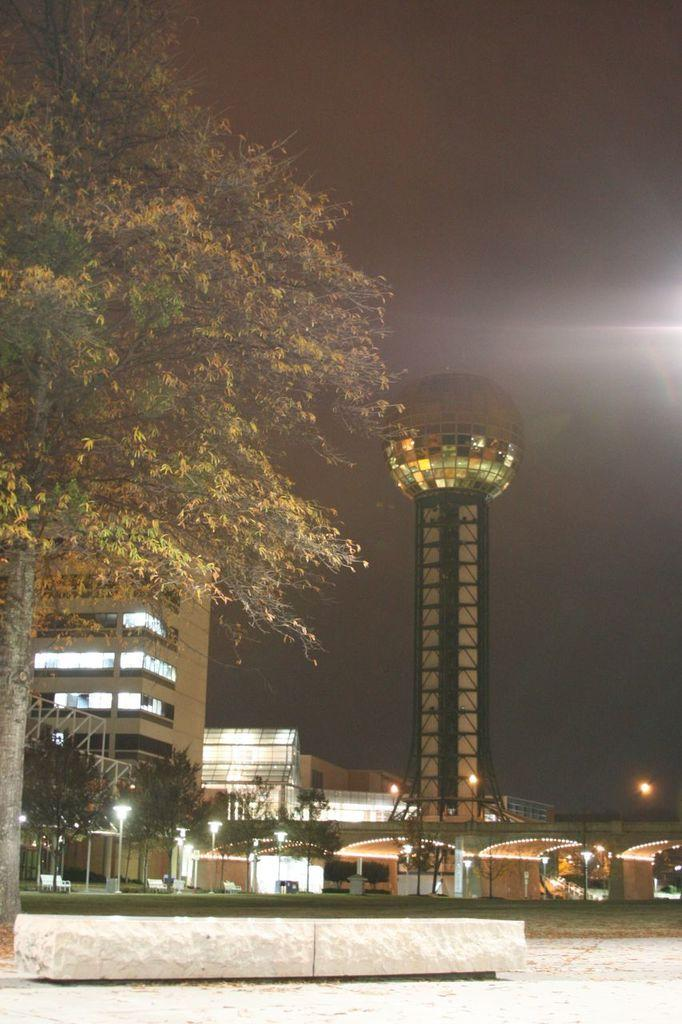What type of structures can be seen in the image? There are buildings in the image. What feature is visible on the buildings? There are windows visible in the image. What type of vegetation is present in the image? There are trees in the image. What type of street furniture can be seen in the image? There are light-poles in the image. What tall structure is present in the image? There is a tower in the image. What part of the natural environment is visible in the image? The sky is visible in the image. What type of pie is being served at the event in the image? There is no event or pie present in the image. How much money is being exchanged between the people in the image? There are no people or money being exchanged in the image. 